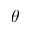<formula> <loc_0><loc_0><loc_500><loc_500>\theta</formula> 